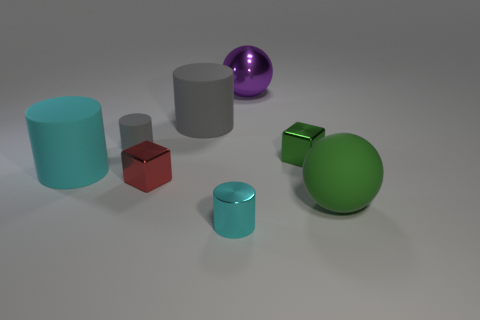Can you speculate on the size relations between these objects? From the perspective given, there seems to be a variety of sizes. For example, the green spherical object in the foreground looks larger compared to the red and cyan blocks due to its proximity. However, without a clear frame of reference or known sizes, exact size relations are speculative. 